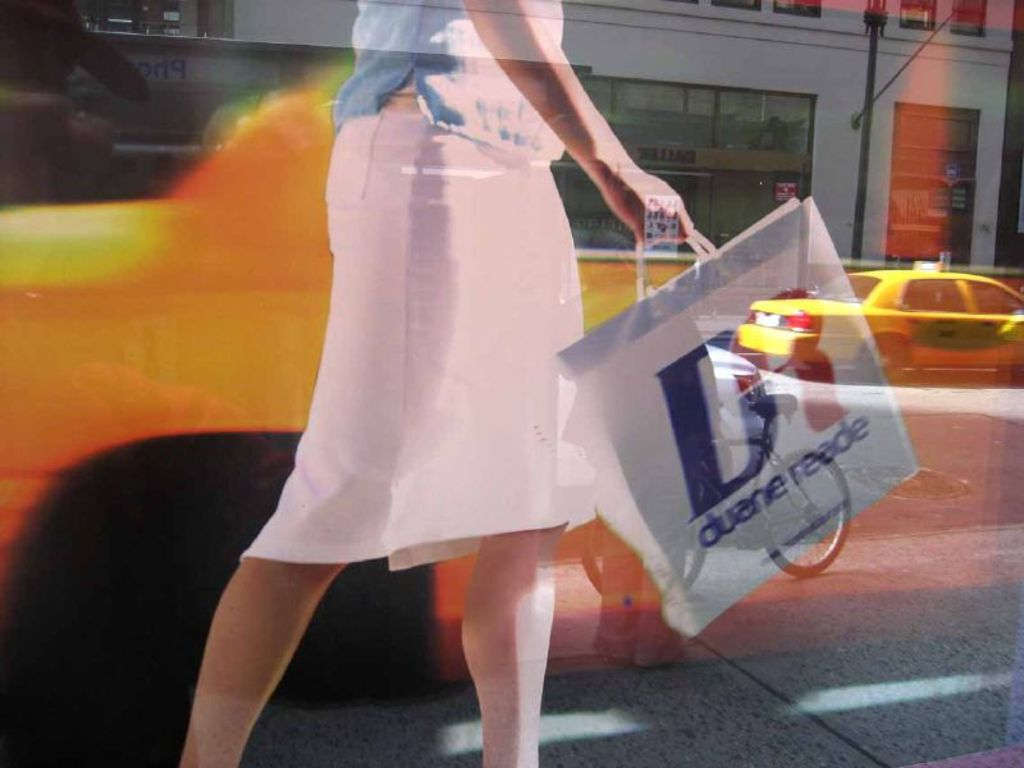Describe the mood conveyed by the woman's posture and the setting. The woman's posture, with her determined stride and the swing of her shopping bag, conveys a sense of purpose and energy. This, combined with the vibrant city backdrop, creates a dynamic mood, typical of a bustling urban environment. 